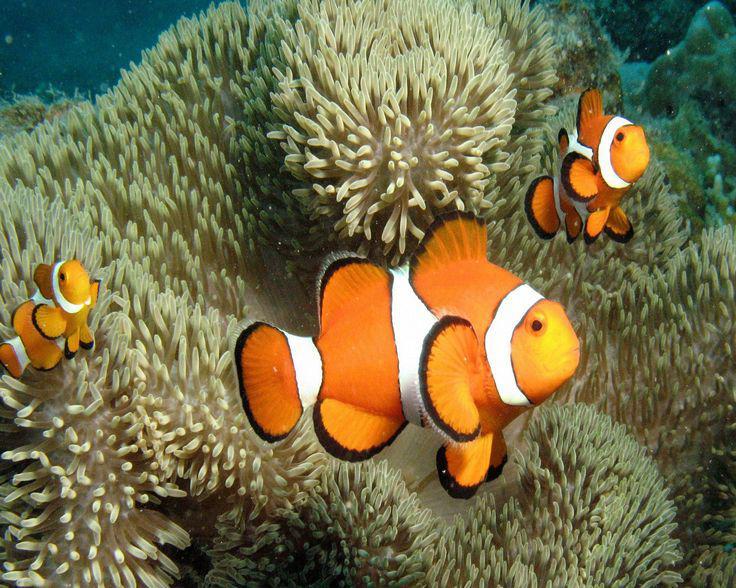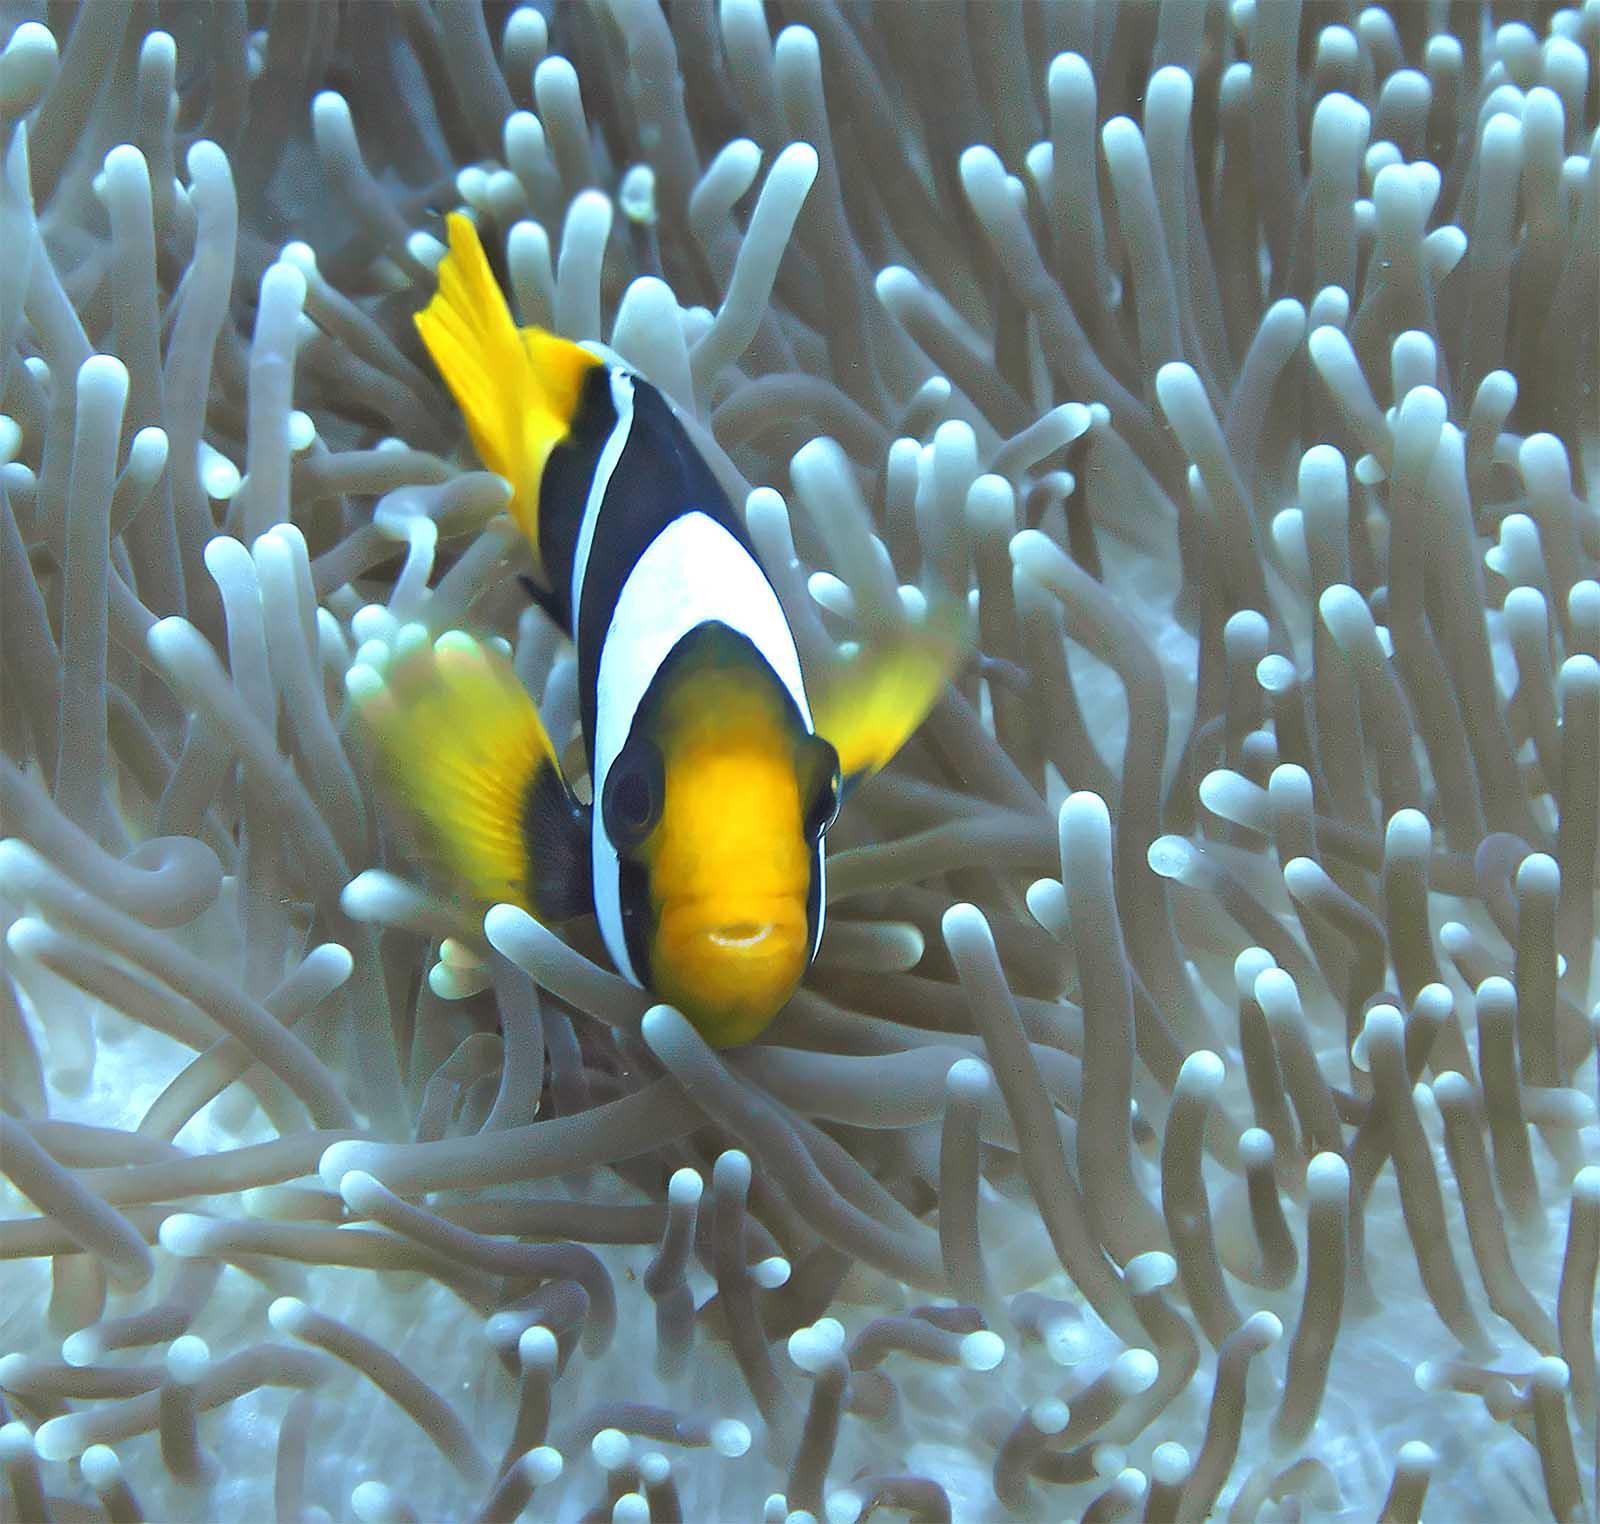The first image is the image on the left, the second image is the image on the right. For the images shown, is this caption "In one of the images there are at least three orange fish swimming around a large number of sea anemone." true? Answer yes or no. Yes. The first image is the image on the left, the second image is the image on the right. Analyze the images presented: Is the assertion "One image shows exactly three orange-and-white clown fish swimming by an anemone." valid? Answer yes or no. Yes. 